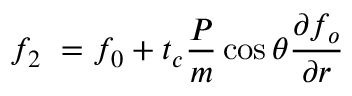Convert formula to latex. <formula><loc_0><loc_0><loc_500><loc_500>f _ { 2 } \ = f _ { 0 } + t _ { c } \frac { P } { m } \cos \theta \frac { \partial f _ { o } } { \partial r }</formula> 